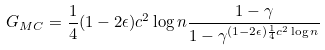<formula> <loc_0><loc_0><loc_500><loc_500>G _ { M C } = \frac { 1 } { 4 } ( 1 - 2 \epsilon ) c ^ { 2 } \log { n } \frac { 1 - \gamma } { 1 - \gamma ^ { ( 1 - 2 \epsilon ) \frac { 1 } { 4 } c ^ { 2 } \log { n } } }</formula> 